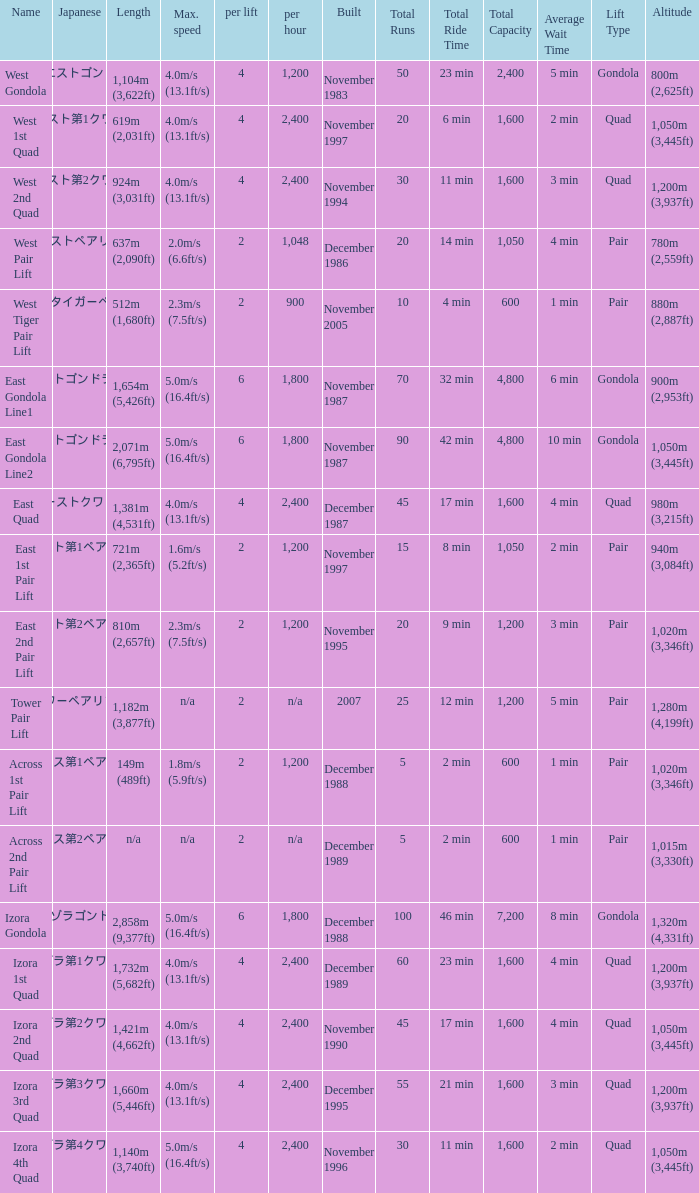How heavy is the  maximum 6.0. 